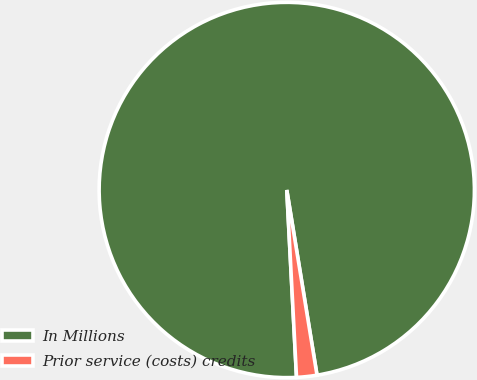Convert chart to OTSL. <chart><loc_0><loc_0><loc_500><loc_500><pie_chart><fcel>In Millions<fcel>Prior service (costs) credits<nl><fcel>98.25%<fcel>1.75%<nl></chart> 